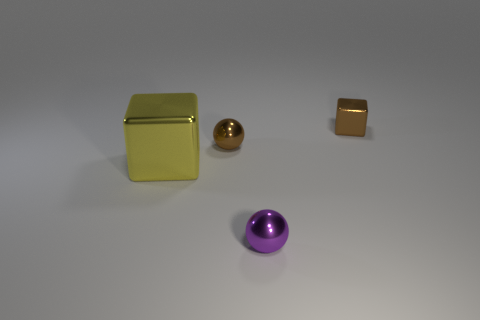Do the tiny thing that is on the right side of the tiny purple metal object and the metallic object in front of the big yellow metal thing have the same color?
Provide a short and direct response. No. Are there any other things that have the same color as the large shiny object?
Provide a short and direct response. No. What is the color of the tiny cube?
Offer a terse response. Brown. Are any large blue shiny things visible?
Offer a very short reply. No. Are there any tiny brown blocks behind the tiny brown metal block?
Offer a very short reply. No. What is the material of the brown object that is the same shape as the small purple thing?
Provide a succinct answer. Metal. Are there any other things that are the same material as the large thing?
Keep it short and to the point. Yes. How many tiny balls are in front of the brown shiny thing in front of the brown thing that is right of the tiny purple shiny sphere?
Offer a very short reply. 1. What number of brown metallic objects have the same shape as the purple shiny thing?
Make the answer very short. 1. There is a block left of the small metal cube; does it have the same color as the tiny cube?
Your answer should be compact. No. 